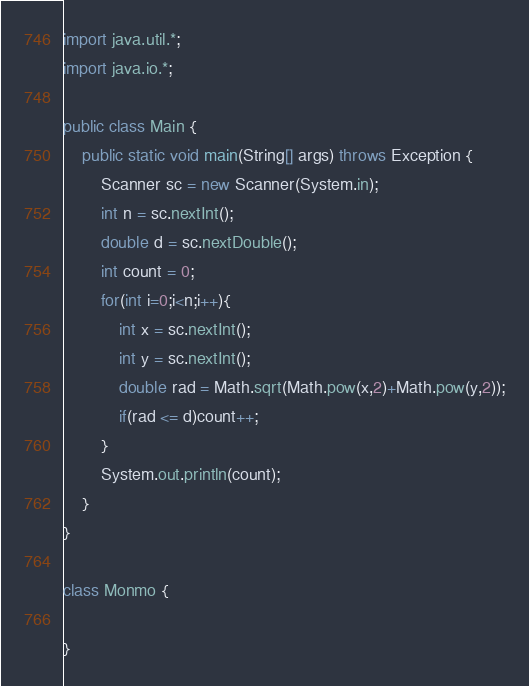Convert code to text. <code><loc_0><loc_0><loc_500><loc_500><_Java_>import java.util.*;
import java.io.*;

public class Main {
    public static void main(String[] args) throws Exception {
        Scanner sc = new Scanner(System.in);
        int n = sc.nextInt(); 
        double d = sc.nextDouble(); 
        int count = 0;
        for(int i=0;i<n;i++){
            int x = sc.nextInt();
            int y = sc.nextInt();
            double rad = Math.sqrt(Math.pow(x,2)+Math.pow(y,2));
            if(rad <= d)count++;
        }
        System.out.println(count);
    }
}

class Monmo {
    
}
</code> 